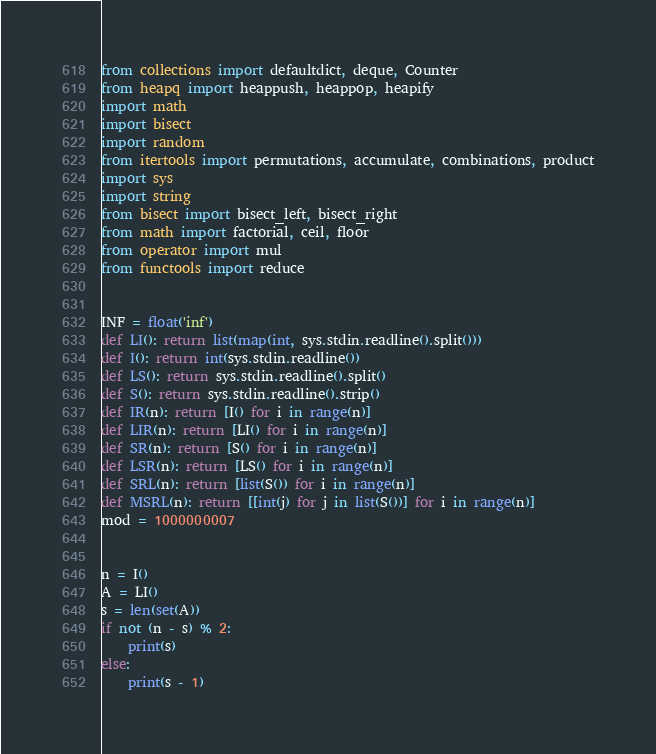<code> <loc_0><loc_0><loc_500><loc_500><_Python_>from collections import defaultdict, deque, Counter
from heapq import heappush, heappop, heapify
import math
import bisect
import random
from itertools import permutations, accumulate, combinations, product
import sys
import string
from bisect import bisect_left, bisect_right
from math import factorial, ceil, floor
from operator import mul
from functools import reduce


INF = float('inf')
def LI(): return list(map(int, sys.stdin.readline().split()))
def I(): return int(sys.stdin.readline())
def LS(): return sys.stdin.readline().split()
def S(): return sys.stdin.readline().strip()
def IR(n): return [I() for i in range(n)]
def LIR(n): return [LI() for i in range(n)]
def SR(n): return [S() for i in range(n)]
def LSR(n): return [LS() for i in range(n)]
def SRL(n): return [list(S()) for i in range(n)]
def MSRL(n): return [[int(j) for j in list(S())] for i in range(n)]
mod = 1000000007


n = I()
A = LI()
s = len(set(A))
if not (n - s) % 2:
    print(s)
else:
    print(s - 1)</code> 